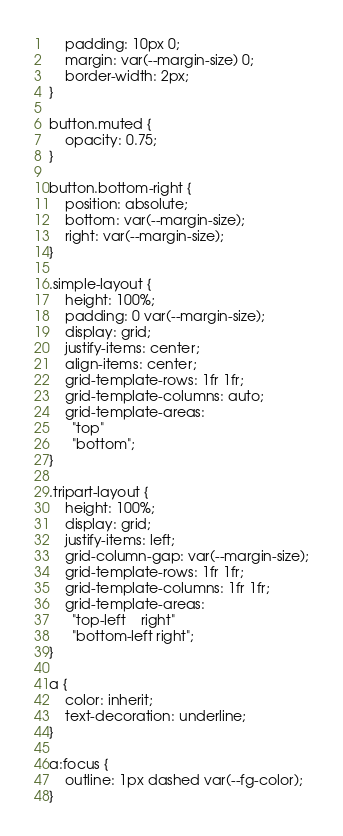Convert code to text. <code><loc_0><loc_0><loc_500><loc_500><_CSS_>    padding: 10px 0;
    margin: var(--margin-size) 0;
    border-width: 2px;
}

button.muted {
    opacity: 0.75;
}

button.bottom-right {
    position: absolute;
    bottom: var(--margin-size);
    right: var(--margin-size);
}

.simple-layout {
    height: 100%;
    padding: 0 var(--margin-size);
    display: grid;
    justify-items: center;
    align-items: center;
    grid-template-rows: 1fr 1fr;
    grid-template-columns: auto;
    grid-template-areas:
      "top"
      "bottom";
}

.tripart-layout {
    height: 100%;
    display: grid;
    justify-items: left;
    grid-column-gap: var(--margin-size);
    grid-template-rows: 1fr 1fr;
    grid-template-columns: 1fr 1fr;
    grid-template-areas:
      "top-left    right"
      "bottom-left right";
}

a {
    color: inherit;
    text-decoration: underline;
}

a:focus {
    outline: 1px dashed var(--fg-color);
}
</code> 